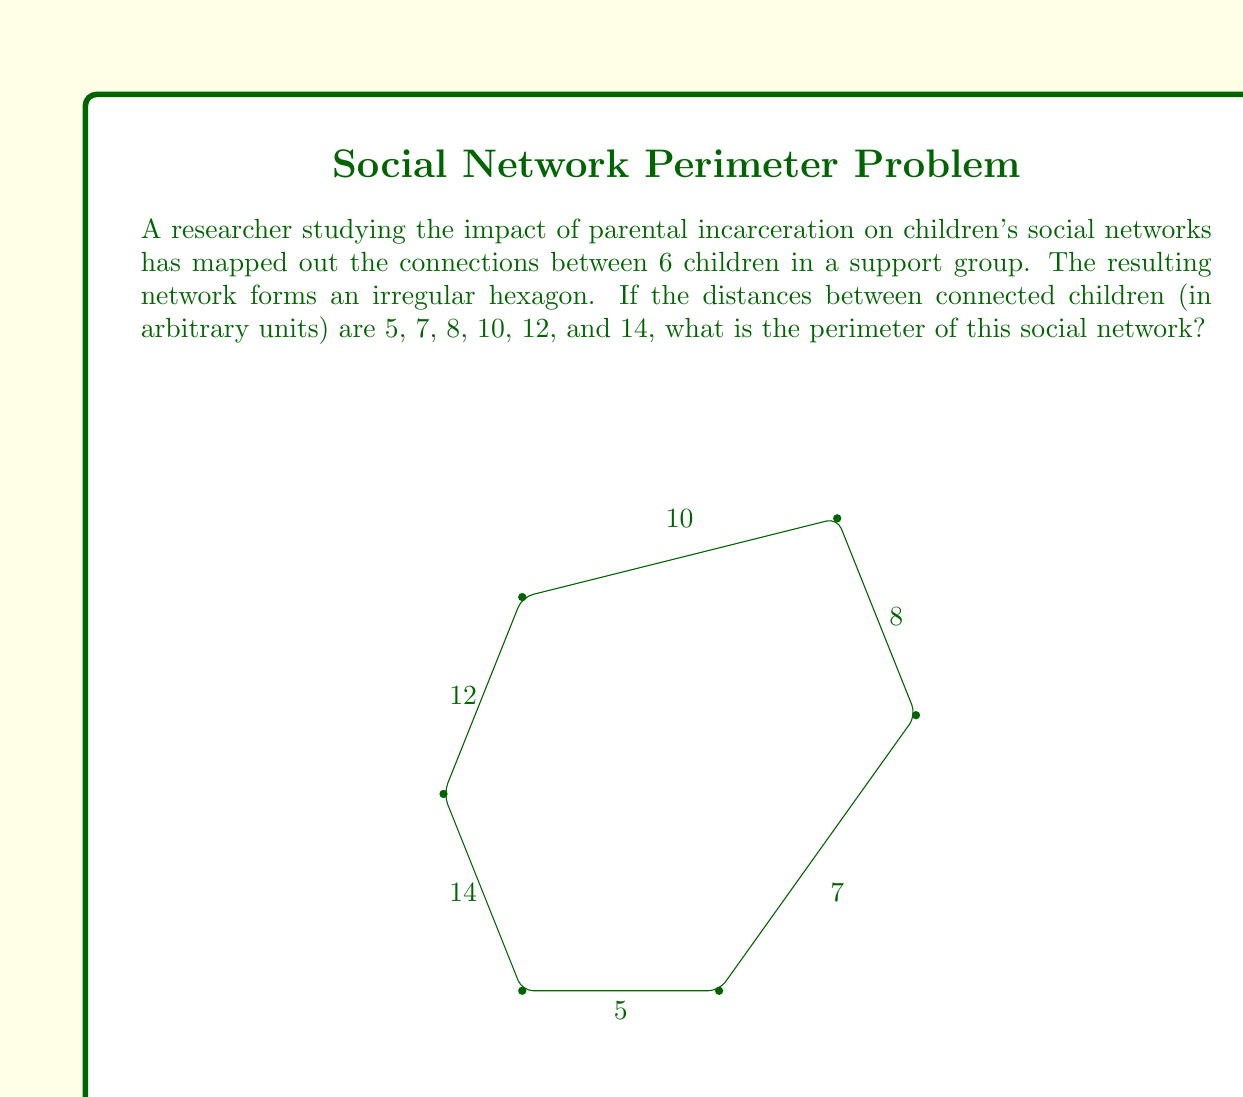Could you help me with this problem? To find the perimeter of the irregular hexagon representing the social network, we need to sum up all the side lengths:

1) The given side lengths are: 5, 7, 8, 10, 12, and 14 units.

2) We can use the formula for the perimeter of a polygon:
   $$P = \sum_{i=1}^n s_i$$
   where $P$ is the perimeter, $n$ is the number of sides, and $s_i$ are the individual side lengths.

3) Substituting our values:
   $$P = 5 + 7 + 8 + 10 + 12 + 14$$

4) Calculating the sum:
   $$P = 56$$

Therefore, the perimeter of the social network represented by this irregular hexagon is 56 units.
Answer: 56 units 